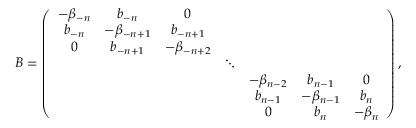Convert formula to latex. <formula><loc_0><loc_0><loc_500><loc_500>B = \left ( \begin{array} { c c c c c c c } { { - \beta _ { - n } } } & { { b _ { - n } } } & { 0 } \\ { { b _ { - n } } } & { { - \beta _ { - n + 1 } } } & { { b _ { - n + 1 } } } \\ { 0 } & { { b _ { - n + 1 } } } & { { - \beta _ { - n + 2 } } } & { \ddots } & { { - \beta _ { n - 2 } } } & { { b _ { n - 1 } } } & { 0 } & { { b _ { n - 1 } } } & { { - \beta _ { n - 1 } } } & { { b _ { n } } } & { 0 } & { { b _ { n } } } & { { - \beta _ { n } } } \end{array} \right ) ,</formula> 